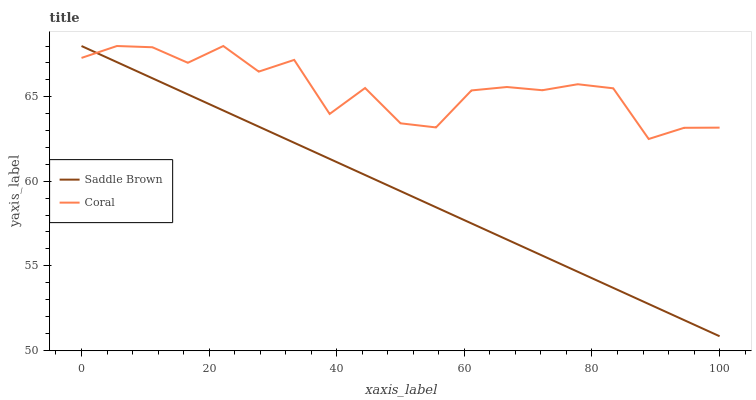Does Saddle Brown have the maximum area under the curve?
Answer yes or no. No. Is Saddle Brown the roughest?
Answer yes or no. No. 